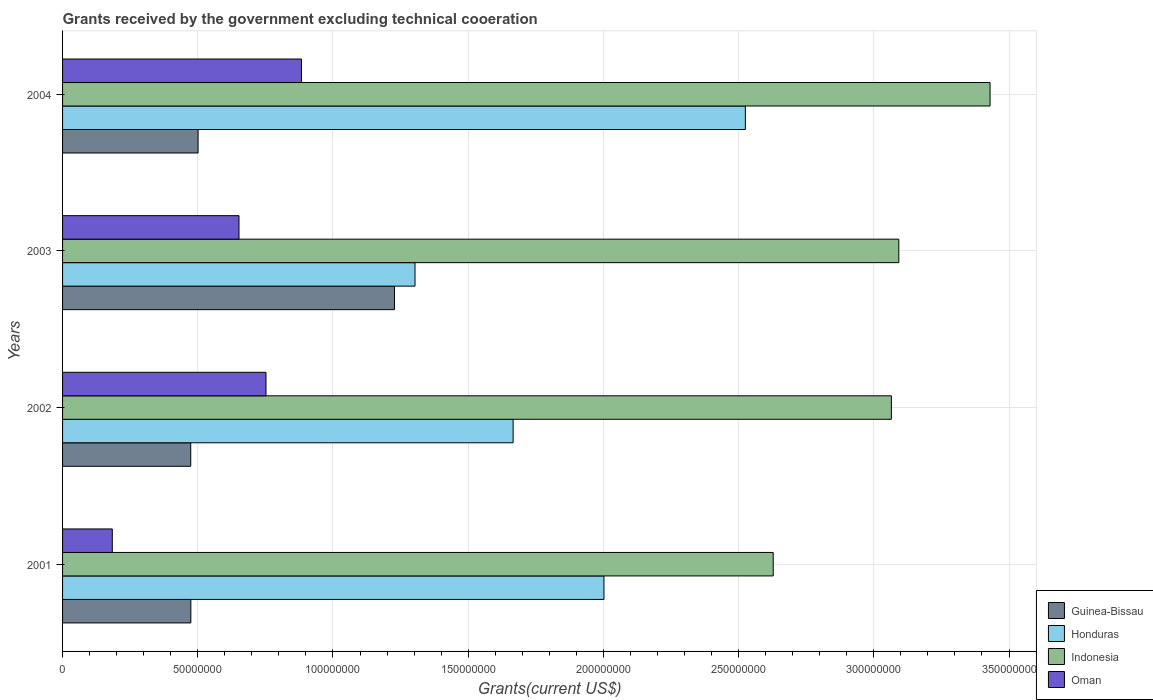How many different coloured bars are there?
Offer a terse response. 4. Are the number of bars per tick equal to the number of legend labels?
Offer a terse response. Yes. How many bars are there on the 4th tick from the top?
Your response must be concise. 4. How many bars are there on the 2nd tick from the bottom?
Your answer should be compact. 4. What is the label of the 3rd group of bars from the top?
Provide a short and direct response. 2002. What is the total grants received by the government in Honduras in 2002?
Your answer should be compact. 1.67e+08. Across all years, what is the maximum total grants received by the government in Oman?
Provide a succinct answer. 8.84e+07. Across all years, what is the minimum total grants received by the government in Oman?
Your answer should be compact. 1.84e+07. In which year was the total grants received by the government in Honduras minimum?
Offer a terse response. 2003. What is the total total grants received by the government in Honduras in the graph?
Your answer should be compact. 7.50e+08. What is the difference between the total grants received by the government in Oman in 2003 and that in 2004?
Offer a very short reply. -2.31e+07. What is the difference between the total grants received by the government in Oman in 2001 and the total grants received by the government in Honduras in 2002?
Provide a succinct answer. -1.48e+08. What is the average total grants received by the government in Guinea-Bissau per year?
Your answer should be very brief. 6.69e+07. In the year 2003, what is the difference between the total grants received by the government in Oman and total grants received by the government in Honduras?
Keep it short and to the point. -6.51e+07. What is the ratio of the total grants received by the government in Oman in 2001 to that in 2003?
Provide a short and direct response. 0.28. Is the total grants received by the government in Guinea-Bissau in 2001 less than that in 2002?
Give a very brief answer. No. What is the difference between the highest and the second highest total grants received by the government in Guinea-Bissau?
Your answer should be very brief. 7.26e+07. What is the difference between the highest and the lowest total grants received by the government in Indonesia?
Give a very brief answer. 8.02e+07. In how many years, is the total grants received by the government in Indonesia greater than the average total grants received by the government in Indonesia taken over all years?
Provide a succinct answer. 3. Is it the case that in every year, the sum of the total grants received by the government in Indonesia and total grants received by the government in Guinea-Bissau is greater than the sum of total grants received by the government in Oman and total grants received by the government in Honduras?
Provide a succinct answer. No. What does the 4th bar from the top in 2002 represents?
Provide a succinct answer. Guinea-Bissau. Is it the case that in every year, the sum of the total grants received by the government in Indonesia and total grants received by the government in Honduras is greater than the total grants received by the government in Guinea-Bissau?
Your response must be concise. Yes. How many bars are there?
Offer a very short reply. 16. What is the difference between two consecutive major ticks on the X-axis?
Your answer should be very brief. 5.00e+07. Are the values on the major ticks of X-axis written in scientific E-notation?
Ensure brevity in your answer.  No. How many legend labels are there?
Provide a short and direct response. 4. How are the legend labels stacked?
Ensure brevity in your answer.  Vertical. What is the title of the graph?
Make the answer very short. Grants received by the government excluding technical cooeration. What is the label or title of the X-axis?
Your response must be concise. Grants(current US$). What is the label or title of the Y-axis?
Provide a succinct answer. Years. What is the Grants(current US$) of Guinea-Bissau in 2001?
Offer a terse response. 4.74e+07. What is the Grants(current US$) in Honduras in 2001?
Offer a very short reply. 2.00e+08. What is the Grants(current US$) in Indonesia in 2001?
Ensure brevity in your answer.  2.63e+08. What is the Grants(current US$) in Oman in 2001?
Keep it short and to the point. 1.84e+07. What is the Grants(current US$) of Guinea-Bissau in 2002?
Offer a terse response. 4.74e+07. What is the Grants(current US$) in Honduras in 2002?
Offer a very short reply. 1.67e+08. What is the Grants(current US$) in Indonesia in 2002?
Make the answer very short. 3.06e+08. What is the Grants(current US$) in Oman in 2002?
Your answer should be very brief. 7.52e+07. What is the Grants(current US$) of Guinea-Bissau in 2003?
Your answer should be compact. 1.23e+08. What is the Grants(current US$) of Honduras in 2003?
Offer a very short reply. 1.30e+08. What is the Grants(current US$) in Indonesia in 2003?
Offer a terse response. 3.09e+08. What is the Grants(current US$) in Oman in 2003?
Provide a succinct answer. 6.52e+07. What is the Grants(current US$) of Guinea-Bissau in 2004?
Ensure brevity in your answer.  5.01e+07. What is the Grants(current US$) in Honduras in 2004?
Your answer should be compact. 2.52e+08. What is the Grants(current US$) of Indonesia in 2004?
Keep it short and to the point. 3.43e+08. What is the Grants(current US$) of Oman in 2004?
Ensure brevity in your answer.  8.84e+07. Across all years, what is the maximum Grants(current US$) of Guinea-Bissau?
Offer a terse response. 1.23e+08. Across all years, what is the maximum Grants(current US$) of Honduras?
Your answer should be compact. 2.52e+08. Across all years, what is the maximum Grants(current US$) in Indonesia?
Ensure brevity in your answer.  3.43e+08. Across all years, what is the maximum Grants(current US$) of Oman?
Give a very brief answer. 8.84e+07. Across all years, what is the minimum Grants(current US$) in Guinea-Bissau?
Your answer should be very brief. 4.74e+07. Across all years, what is the minimum Grants(current US$) in Honduras?
Give a very brief answer. 1.30e+08. Across all years, what is the minimum Grants(current US$) of Indonesia?
Keep it short and to the point. 2.63e+08. Across all years, what is the minimum Grants(current US$) of Oman?
Ensure brevity in your answer.  1.84e+07. What is the total Grants(current US$) in Guinea-Bissau in the graph?
Ensure brevity in your answer.  2.68e+08. What is the total Grants(current US$) in Honduras in the graph?
Offer a very short reply. 7.50e+08. What is the total Grants(current US$) of Indonesia in the graph?
Your answer should be very brief. 1.22e+09. What is the total Grants(current US$) in Oman in the graph?
Provide a succinct answer. 2.47e+08. What is the difference between the Grants(current US$) of Guinea-Bissau in 2001 and that in 2002?
Your answer should be very brief. 4.00e+04. What is the difference between the Grants(current US$) in Honduras in 2001 and that in 2002?
Make the answer very short. 3.36e+07. What is the difference between the Grants(current US$) in Indonesia in 2001 and that in 2002?
Offer a terse response. -4.37e+07. What is the difference between the Grants(current US$) in Oman in 2001 and that in 2002?
Offer a very short reply. -5.68e+07. What is the difference between the Grants(current US$) of Guinea-Bissau in 2001 and that in 2003?
Provide a short and direct response. -7.53e+07. What is the difference between the Grants(current US$) in Honduras in 2001 and that in 2003?
Keep it short and to the point. 6.99e+07. What is the difference between the Grants(current US$) in Indonesia in 2001 and that in 2003?
Your answer should be compact. -4.64e+07. What is the difference between the Grants(current US$) in Oman in 2001 and that in 2003?
Your answer should be compact. -4.68e+07. What is the difference between the Grants(current US$) of Guinea-Bissau in 2001 and that in 2004?
Give a very brief answer. -2.68e+06. What is the difference between the Grants(current US$) in Honduras in 2001 and that in 2004?
Your response must be concise. -5.23e+07. What is the difference between the Grants(current US$) of Indonesia in 2001 and that in 2004?
Give a very brief answer. -8.02e+07. What is the difference between the Grants(current US$) of Oman in 2001 and that in 2004?
Your answer should be very brief. -7.00e+07. What is the difference between the Grants(current US$) in Guinea-Bissau in 2002 and that in 2003?
Keep it short and to the point. -7.53e+07. What is the difference between the Grants(current US$) of Honduras in 2002 and that in 2003?
Keep it short and to the point. 3.63e+07. What is the difference between the Grants(current US$) in Indonesia in 2002 and that in 2003?
Offer a terse response. -2.75e+06. What is the difference between the Grants(current US$) in Oman in 2002 and that in 2003?
Your response must be concise. 9.99e+06. What is the difference between the Grants(current US$) in Guinea-Bissau in 2002 and that in 2004?
Your response must be concise. -2.72e+06. What is the difference between the Grants(current US$) of Honduras in 2002 and that in 2004?
Provide a short and direct response. -8.59e+07. What is the difference between the Grants(current US$) of Indonesia in 2002 and that in 2004?
Provide a succinct answer. -3.65e+07. What is the difference between the Grants(current US$) in Oman in 2002 and that in 2004?
Make the answer very short. -1.31e+07. What is the difference between the Grants(current US$) of Guinea-Bissau in 2003 and that in 2004?
Provide a succinct answer. 7.26e+07. What is the difference between the Grants(current US$) in Honduras in 2003 and that in 2004?
Provide a short and direct response. -1.22e+08. What is the difference between the Grants(current US$) of Indonesia in 2003 and that in 2004?
Keep it short and to the point. -3.37e+07. What is the difference between the Grants(current US$) in Oman in 2003 and that in 2004?
Ensure brevity in your answer.  -2.31e+07. What is the difference between the Grants(current US$) in Guinea-Bissau in 2001 and the Grants(current US$) in Honduras in 2002?
Offer a terse response. -1.19e+08. What is the difference between the Grants(current US$) of Guinea-Bissau in 2001 and the Grants(current US$) of Indonesia in 2002?
Keep it short and to the point. -2.59e+08. What is the difference between the Grants(current US$) of Guinea-Bissau in 2001 and the Grants(current US$) of Oman in 2002?
Your answer should be very brief. -2.78e+07. What is the difference between the Grants(current US$) of Honduras in 2001 and the Grants(current US$) of Indonesia in 2002?
Your response must be concise. -1.06e+08. What is the difference between the Grants(current US$) of Honduras in 2001 and the Grants(current US$) of Oman in 2002?
Your response must be concise. 1.25e+08. What is the difference between the Grants(current US$) of Indonesia in 2001 and the Grants(current US$) of Oman in 2002?
Keep it short and to the point. 1.88e+08. What is the difference between the Grants(current US$) of Guinea-Bissau in 2001 and the Grants(current US$) of Honduras in 2003?
Your answer should be compact. -8.29e+07. What is the difference between the Grants(current US$) in Guinea-Bissau in 2001 and the Grants(current US$) in Indonesia in 2003?
Make the answer very short. -2.62e+08. What is the difference between the Grants(current US$) in Guinea-Bissau in 2001 and the Grants(current US$) in Oman in 2003?
Provide a short and direct response. -1.78e+07. What is the difference between the Grants(current US$) in Honduras in 2001 and the Grants(current US$) in Indonesia in 2003?
Your response must be concise. -1.09e+08. What is the difference between the Grants(current US$) in Honduras in 2001 and the Grants(current US$) in Oman in 2003?
Offer a terse response. 1.35e+08. What is the difference between the Grants(current US$) in Indonesia in 2001 and the Grants(current US$) in Oman in 2003?
Your answer should be very brief. 1.98e+08. What is the difference between the Grants(current US$) of Guinea-Bissau in 2001 and the Grants(current US$) of Honduras in 2004?
Your answer should be very brief. -2.05e+08. What is the difference between the Grants(current US$) in Guinea-Bissau in 2001 and the Grants(current US$) in Indonesia in 2004?
Ensure brevity in your answer.  -2.96e+08. What is the difference between the Grants(current US$) of Guinea-Bissau in 2001 and the Grants(current US$) of Oman in 2004?
Provide a short and direct response. -4.09e+07. What is the difference between the Grants(current US$) in Honduras in 2001 and the Grants(current US$) in Indonesia in 2004?
Offer a terse response. -1.43e+08. What is the difference between the Grants(current US$) in Honduras in 2001 and the Grants(current US$) in Oman in 2004?
Give a very brief answer. 1.12e+08. What is the difference between the Grants(current US$) of Indonesia in 2001 and the Grants(current US$) of Oman in 2004?
Your response must be concise. 1.74e+08. What is the difference between the Grants(current US$) of Guinea-Bissau in 2002 and the Grants(current US$) of Honduras in 2003?
Give a very brief answer. -8.29e+07. What is the difference between the Grants(current US$) of Guinea-Bissau in 2002 and the Grants(current US$) of Indonesia in 2003?
Make the answer very short. -2.62e+08. What is the difference between the Grants(current US$) in Guinea-Bissau in 2002 and the Grants(current US$) in Oman in 2003?
Keep it short and to the point. -1.78e+07. What is the difference between the Grants(current US$) of Honduras in 2002 and the Grants(current US$) of Indonesia in 2003?
Your answer should be very brief. -1.43e+08. What is the difference between the Grants(current US$) in Honduras in 2002 and the Grants(current US$) in Oman in 2003?
Offer a very short reply. 1.01e+08. What is the difference between the Grants(current US$) in Indonesia in 2002 and the Grants(current US$) in Oman in 2003?
Provide a short and direct response. 2.41e+08. What is the difference between the Grants(current US$) in Guinea-Bissau in 2002 and the Grants(current US$) in Honduras in 2004?
Give a very brief answer. -2.05e+08. What is the difference between the Grants(current US$) in Guinea-Bissau in 2002 and the Grants(current US$) in Indonesia in 2004?
Offer a terse response. -2.96e+08. What is the difference between the Grants(current US$) of Guinea-Bissau in 2002 and the Grants(current US$) of Oman in 2004?
Your response must be concise. -4.10e+07. What is the difference between the Grants(current US$) of Honduras in 2002 and the Grants(current US$) of Indonesia in 2004?
Your response must be concise. -1.76e+08. What is the difference between the Grants(current US$) in Honduras in 2002 and the Grants(current US$) in Oman in 2004?
Offer a very short reply. 7.83e+07. What is the difference between the Grants(current US$) in Indonesia in 2002 and the Grants(current US$) in Oman in 2004?
Give a very brief answer. 2.18e+08. What is the difference between the Grants(current US$) in Guinea-Bissau in 2003 and the Grants(current US$) in Honduras in 2004?
Provide a short and direct response. -1.30e+08. What is the difference between the Grants(current US$) of Guinea-Bissau in 2003 and the Grants(current US$) of Indonesia in 2004?
Your answer should be very brief. -2.20e+08. What is the difference between the Grants(current US$) in Guinea-Bissau in 2003 and the Grants(current US$) in Oman in 2004?
Keep it short and to the point. 3.44e+07. What is the difference between the Grants(current US$) in Honduras in 2003 and the Grants(current US$) in Indonesia in 2004?
Your response must be concise. -2.13e+08. What is the difference between the Grants(current US$) in Honduras in 2003 and the Grants(current US$) in Oman in 2004?
Your answer should be very brief. 4.20e+07. What is the difference between the Grants(current US$) of Indonesia in 2003 and the Grants(current US$) of Oman in 2004?
Ensure brevity in your answer.  2.21e+08. What is the average Grants(current US$) in Guinea-Bissau per year?
Your answer should be very brief. 6.69e+07. What is the average Grants(current US$) in Honduras per year?
Offer a terse response. 1.87e+08. What is the average Grants(current US$) in Indonesia per year?
Provide a succinct answer. 3.05e+08. What is the average Grants(current US$) in Oman per year?
Make the answer very short. 6.18e+07. In the year 2001, what is the difference between the Grants(current US$) in Guinea-Bissau and Grants(current US$) in Honduras?
Your answer should be very brief. -1.53e+08. In the year 2001, what is the difference between the Grants(current US$) of Guinea-Bissau and Grants(current US$) of Indonesia?
Your response must be concise. -2.15e+08. In the year 2001, what is the difference between the Grants(current US$) of Guinea-Bissau and Grants(current US$) of Oman?
Offer a very short reply. 2.90e+07. In the year 2001, what is the difference between the Grants(current US$) in Honduras and Grants(current US$) in Indonesia?
Keep it short and to the point. -6.26e+07. In the year 2001, what is the difference between the Grants(current US$) in Honduras and Grants(current US$) in Oman?
Give a very brief answer. 1.82e+08. In the year 2001, what is the difference between the Grants(current US$) of Indonesia and Grants(current US$) of Oman?
Provide a short and direct response. 2.44e+08. In the year 2002, what is the difference between the Grants(current US$) in Guinea-Bissau and Grants(current US$) in Honduras?
Offer a very short reply. -1.19e+08. In the year 2002, what is the difference between the Grants(current US$) in Guinea-Bissau and Grants(current US$) in Indonesia?
Your response must be concise. -2.59e+08. In the year 2002, what is the difference between the Grants(current US$) of Guinea-Bissau and Grants(current US$) of Oman?
Offer a terse response. -2.78e+07. In the year 2002, what is the difference between the Grants(current US$) in Honduras and Grants(current US$) in Indonesia?
Give a very brief answer. -1.40e+08. In the year 2002, what is the difference between the Grants(current US$) of Honduras and Grants(current US$) of Oman?
Your answer should be compact. 9.14e+07. In the year 2002, what is the difference between the Grants(current US$) of Indonesia and Grants(current US$) of Oman?
Your answer should be very brief. 2.31e+08. In the year 2003, what is the difference between the Grants(current US$) of Guinea-Bissau and Grants(current US$) of Honduras?
Your answer should be very brief. -7.60e+06. In the year 2003, what is the difference between the Grants(current US$) in Guinea-Bissau and Grants(current US$) in Indonesia?
Your answer should be compact. -1.87e+08. In the year 2003, what is the difference between the Grants(current US$) of Guinea-Bissau and Grants(current US$) of Oman?
Offer a terse response. 5.75e+07. In the year 2003, what is the difference between the Grants(current US$) of Honduras and Grants(current US$) of Indonesia?
Keep it short and to the point. -1.79e+08. In the year 2003, what is the difference between the Grants(current US$) in Honduras and Grants(current US$) in Oman?
Offer a terse response. 6.51e+07. In the year 2003, what is the difference between the Grants(current US$) in Indonesia and Grants(current US$) in Oman?
Your answer should be very brief. 2.44e+08. In the year 2004, what is the difference between the Grants(current US$) in Guinea-Bissau and Grants(current US$) in Honduras?
Provide a short and direct response. -2.02e+08. In the year 2004, what is the difference between the Grants(current US$) in Guinea-Bissau and Grants(current US$) in Indonesia?
Keep it short and to the point. -2.93e+08. In the year 2004, what is the difference between the Grants(current US$) in Guinea-Bissau and Grants(current US$) in Oman?
Provide a short and direct response. -3.82e+07. In the year 2004, what is the difference between the Grants(current US$) of Honduras and Grants(current US$) of Indonesia?
Give a very brief answer. -9.05e+07. In the year 2004, what is the difference between the Grants(current US$) in Honduras and Grants(current US$) in Oman?
Keep it short and to the point. 1.64e+08. In the year 2004, what is the difference between the Grants(current US$) of Indonesia and Grants(current US$) of Oman?
Offer a terse response. 2.55e+08. What is the ratio of the Grants(current US$) in Guinea-Bissau in 2001 to that in 2002?
Ensure brevity in your answer.  1. What is the ratio of the Grants(current US$) of Honduras in 2001 to that in 2002?
Offer a very short reply. 1.2. What is the ratio of the Grants(current US$) in Indonesia in 2001 to that in 2002?
Give a very brief answer. 0.86. What is the ratio of the Grants(current US$) in Oman in 2001 to that in 2002?
Ensure brevity in your answer.  0.24. What is the ratio of the Grants(current US$) in Guinea-Bissau in 2001 to that in 2003?
Your response must be concise. 0.39. What is the ratio of the Grants(current US$) in Honduras in 2001 to that in 2003?
Keep it short and to the point. 1.54. What is the ratio of the Grants(current US$) in Indonesia in 2001 to that in 2003?
Keep it short and to the point. 0.85. What is the ratio of the Grants(current US$) of Oman in 2001 to that in 2003?
Give a very brief answer. 0.28. What is the ratio of the Grants(current US$) of Guinea-Bissau in 2001 to that in 2004?
Provide a succinct answer. 0.95. What is the ratio of the Grants(current US$) in Honduras in 2001 to that in 2004?
Provide a succinct answer. 0.79. What is the ratio of the Grants(current US$) of Indonesia in 2001 to that in 2004?
Provide a succinct answer. 0.77. What is the ratio of the Grants(current US$) of Oman in 2001 to that in 2004?
Keep it short and to the point. 0.21. What is the ratio of the Grants(current US$) in Guinea-Bissau in 2002 to that in 2003?
Ensure brevity in your answer.  0.39. What is the ratio of the Grants(current US$) in Honduras in 2002 to that in 2003?
Offer a terse response. 1.28. What is the ratio of the Grants(current US$) of Indonesia in 2002 to that in 2003?
Ensure brevity in your answer.  0.99. What is the ratio of the Grants(current US$) in Oman in 2002 to that in 2003?
Your answer should be compact. 1.15. What is the ratio of the Grants(current US$) of Guinea-Bissau in 2002 to that in 2004?
Your answer should be compact. 0.95. What is the ratio of the Grants(current US$) in Honduras in 2002 to that in 2004?
Your answer should be compact. 0.66. What is the ratio of the Grants(current US$) in Indonesia in 2002 to that in 2004?
Offer a very short reply. 0.89. What is the ratio of the Grants(current US$) of Oman in 2002 to that in 2004?
Offer a very short reply. 0.85. What is the ratio of the Grants(current US$) in Guinea-Bissau in 2003 to that in 2004?
Keep it short and to the point. 2.45. What is the ratio of the Grants(current US$) in Honduras in 2003 to that in 2004?
Offer a very short reply. 0.52. What is the ratio of the Grants(current US$) of Indonesia in 2003 to that in 2004?
Make the answer very short. 0.9. What is the ratio of the Grants(current US$) of Oman in 2003 to that in 2004?
Your answer should be very brief. 0.74. What is the difference between the highest and the second highest Grants(current US$) in Guinea-Bissau?
Give a very brief answer. 7.26e+07. What is the difference between the highest and the second highest Grants(current US$) in Honduras?
Offer a terse response. 5.23e+07. What is the difference between the highest and the second highest Grants(current US$) of Indonesia?
Offer a terse response. 3.37e+07. What is the difference between the highest and the second highest Grants(current US$) of Oman?
Your answer should be very brief. 1.31e+07. What is the difference between the highest and the lowest Grants(current US$) of Guinea-Bissau?
Give a very brief answer. 7.53e+07. What is the difference between the highest and the lowest Grants(current US$) in Honduras?
Give a very brief answer. 1.22e+08. What is the difference between the highest and the lowest Grants(current US$) in Indonesia?
Your answer should be very brief. 8.02e+07. What is the difference between the highest and the lowest Grants(current US$) of Oman?
Make the answer very short. 7.00e+07. 